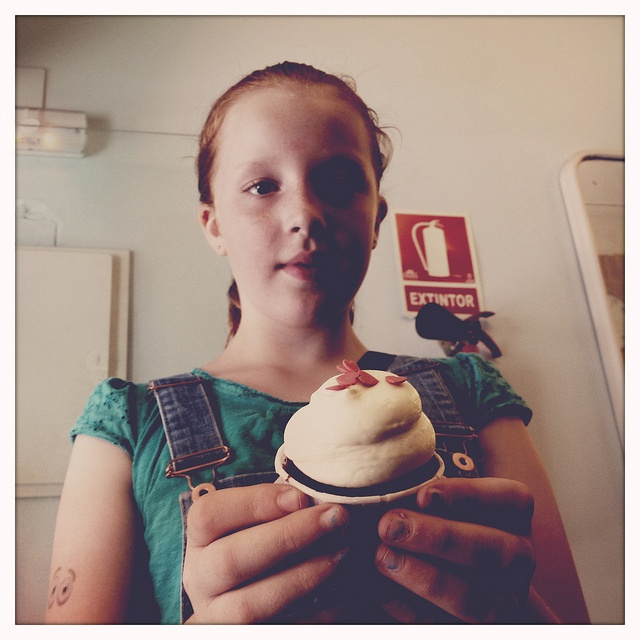Describe the objects in this image and their specific colors. I can see people in white, black, brown, tan, and purple tones and cake in white, tan, brown, and black tones in this image. 